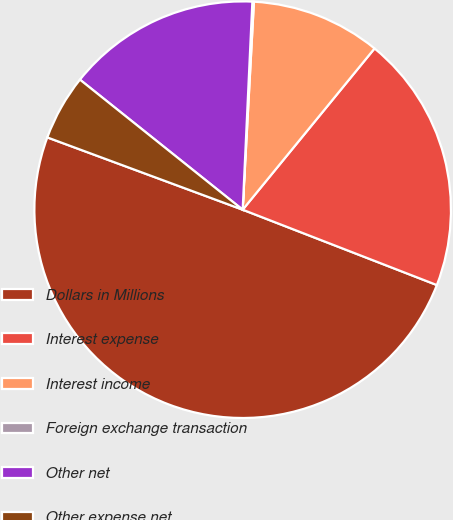<chart> <loc_0><loc_0><loc_500><loc_500><pie_chart><fcel>Dollars in Millions<fcel>Interest expense<fcel>Interest income<fcel>Foreign exchange transaction<fcel>Other net<fcel>Other expense net<nl><fcel>49.75%<fcel>19.98%<fcel>10.05%<fcel>0.12%<fcel>15.01%<fcel>5.09%<nl></chart> 